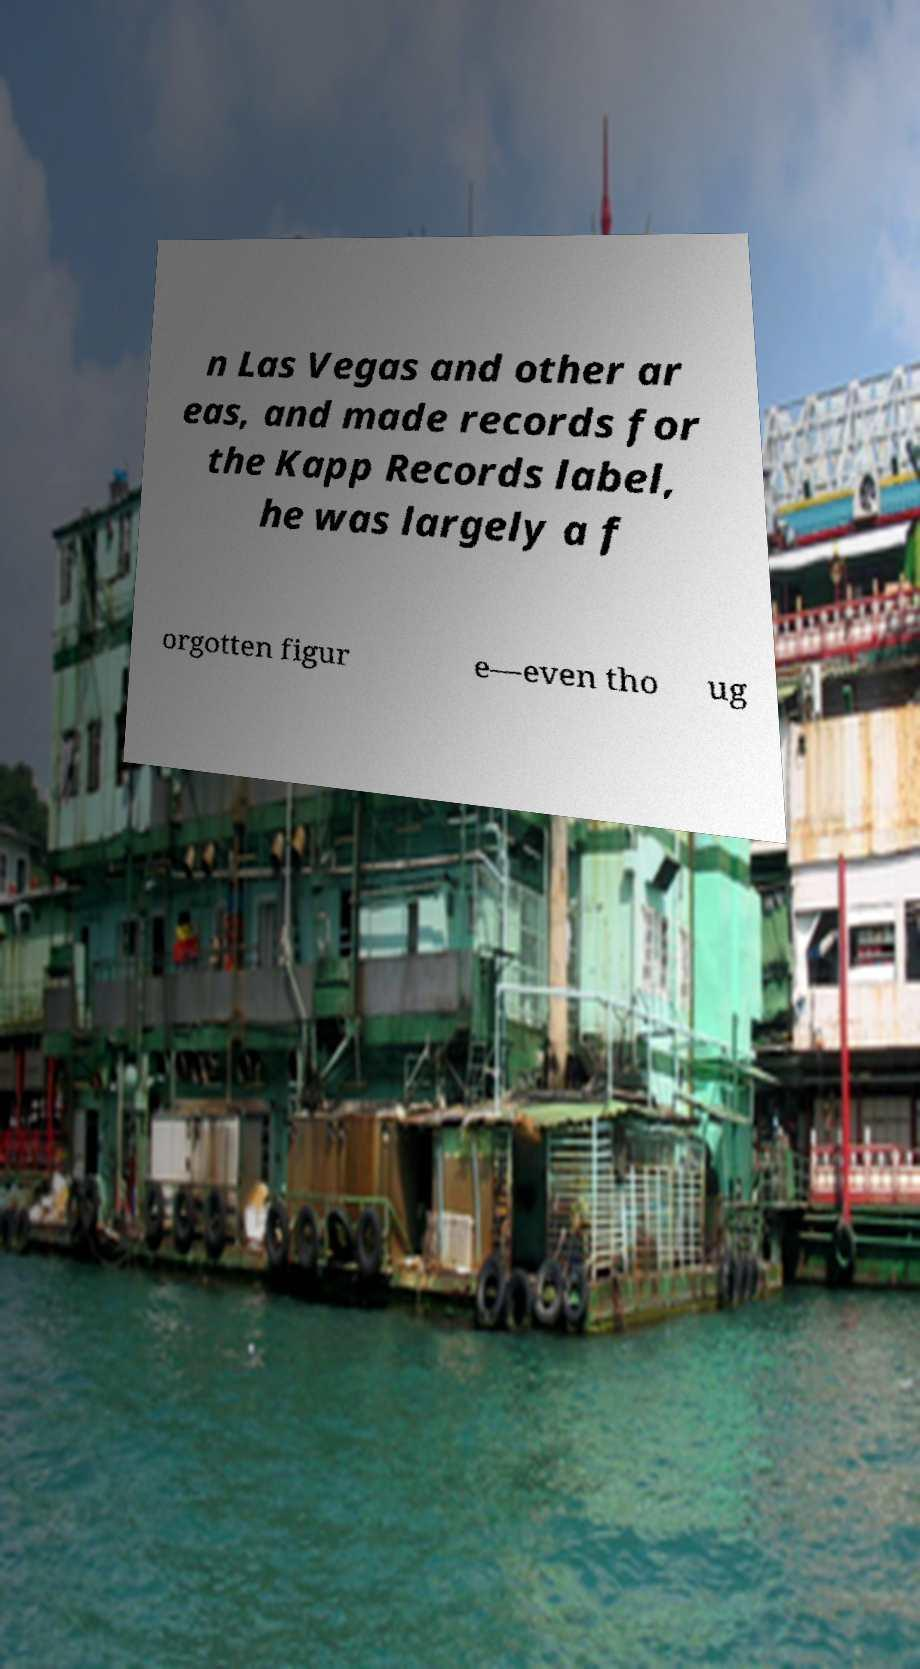Could you assist in decoding the text presented in this image and type it out clearly? n Las Vegas and other ar eas, and made records for the Kapp Records label, he was largely a f orgotten figur e—even tho ug 